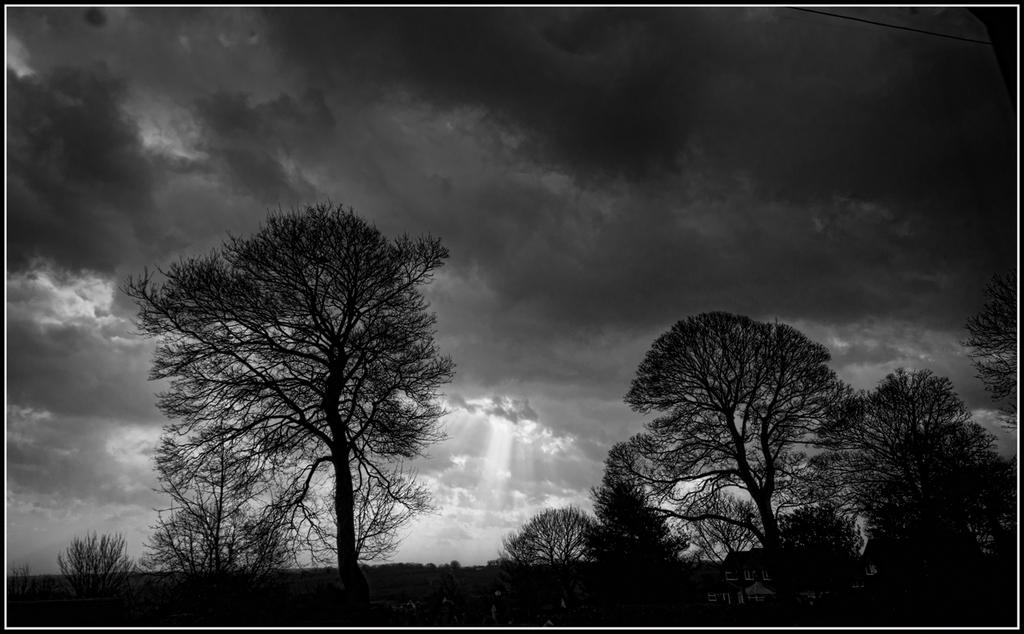What type of vegetation can be seen in the image? There are trees in the image. What is visible in the background of the image? The sky is visible in the background of the image. What is the color scheme of the image? The image is black and white in color. What type of creature can be seen playing in the snow in the image? There is no snow or creature present in the image; it is a black and white image with trees and a visible sky. 